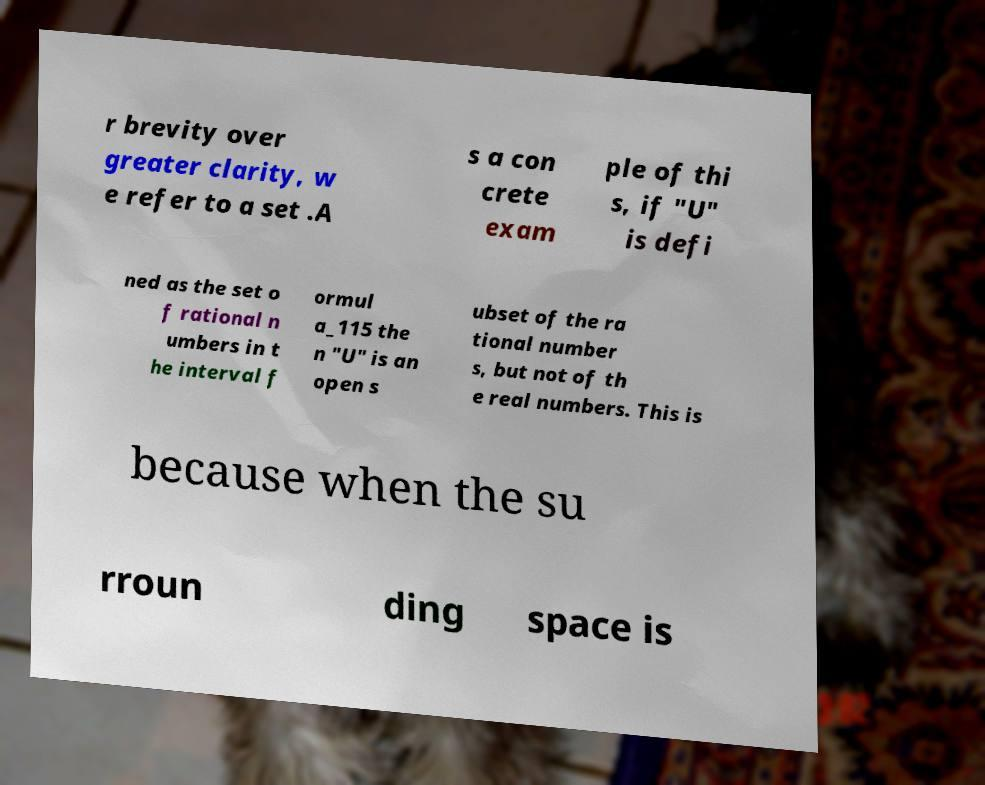What messages or text are displayed in this image? I need them in a readable, typed format. r brevity over greater clarity, w e refer to a set .A s a con crete exam ple of thi s, if "U" is defi ned as the set o f rational n umbers in t he interval f ormul a_115 the n "U" is an open s ubset of the ra tional number s, but not of th e real numbers. This is because when the su rroun ding space is 